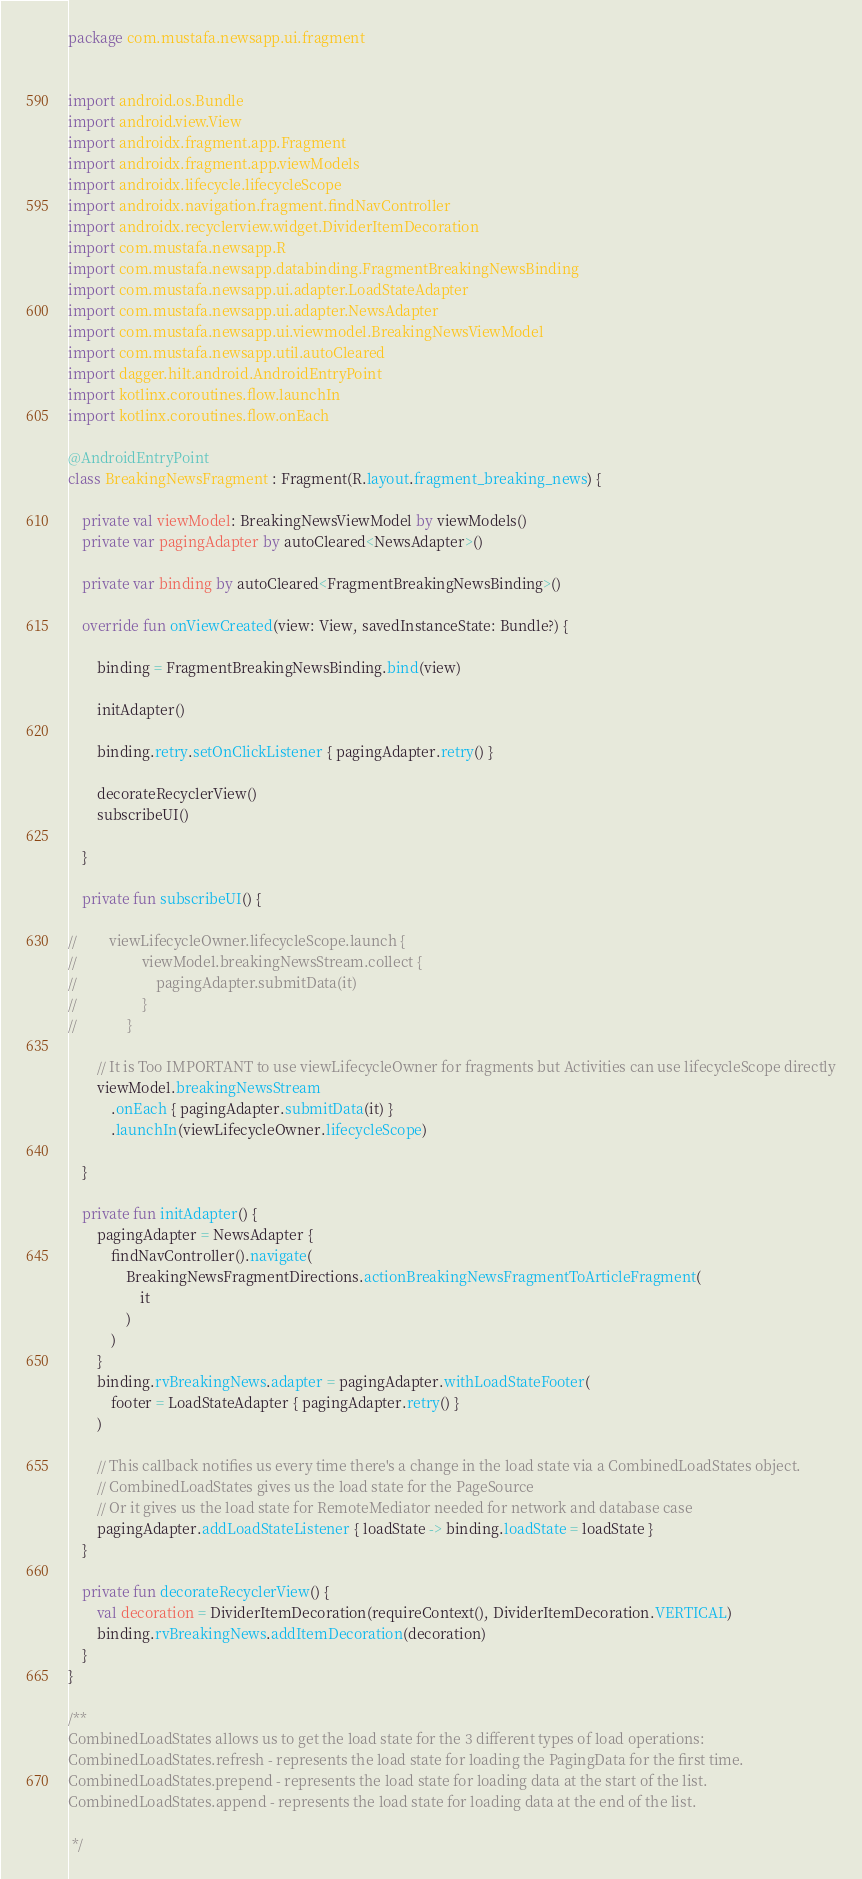Convert code to text. <code><loc_0><loc_0><loc_500><loc_500><_Kotlin_>package com.mustafa.newsapp.ui.fragment


import android.os.Bundle
import android.view.View
import androidx.fragment.app.Fragment
import androidx.fragment.app.viewModels
import androidx.lifecycle.lifecycleScope
import androidx.navigation.fragment.findNavController
import androidx.recyclerview.widget.DividerItemDecoration
import com.mustafa.newsapp.R
import com.mustafa.newsapp.databinding.FragmentBreakingNewsBinding
import com.mustafa.newsapp.ui.adapter.LoadStateAdapter
import com.mustafa.newsapp.ui.adapter.NewsAdapter
import com.mustafa.newsapp.ui.viewmodel.BreakingNewsViewModel
import com.mustafa.newsapp.util.autoCleared
import dagger.hilt.android.AndroidEntryPoint
import kotlinx.coroutines.flow.launchIn
import kotlinx.coroutines.flow.onEach

@AndroidEntryPoint
class BreakingNewsFragment : Fragment(R.layout.fragment_breaking_news) {

    private val viewModel: BreakingNewsViewModel by viewModels()
    private var pagingAdapter by autoCleared<NewsAdapter>()

    private var binding by autoCleared<FragmentBreakingNewsBinding>()

    override fun onViewCreated(view: View, savedInstanceState: Bundle?) {

        binding = FragmentBreakingNewsBinding.bind(view)

        initAdapter()

        binding.retry.setOnClickListener { pagingAdapter.retry() }

        decorateRecyclerView()
        subscribeUI()

    }

    private fun subscribeUI() {

//         viewLifecycleOwner.lifecycleScope.launch {
//                  viewModel.breakingNewsStream.collect {
//                      pagingAdapter.submitData(it)
//                  }
//              }

        // It is Too IMPORTANT to use viewLifecycleOwner for fragments but Activities can use lifecycleScope directly
        viewModel.breakingNewsStream
            .onEach { pagingAdapter.submitData(it) }
            .launchIn(viewLifecycleOwner.lifecycleScope)

    }

    private fun initAdapter() {
        pagingAdapter = NewsAdapter {
            findNavController().navigate(
                BreakingNewsFragmentDirections.actionBreakingNewsFragmentToArticleFragment(
                    it
                )
            )
        }
        binding.rvBreakingNews.adapter = pagingAdapter.withLoadStateFooter(
            footer = LoadStateAdapter { pagingAdapter.retry() }
        )

        // This callback notifies us every time there's a change in the load state via a CombinedLoadStates object.
        // CombinedLoadStates gives us the load state for the PageSource
        // Or it gives us the load state for RemoteMediator needed for network and database case
        pagingAdapter.addLoadStateListener { loadState -> binding.loadState = loadState }
    }

    private fun decorateRecyclerView() {
        val decoration = DividerItemDecoration(requireContext(), DividerItemDecoration.VERTICAL)
        binding.rvBreakingNews.addItemDecoration(decoration)
    }
}

/**
CombinedLoadStates allows us to get the load state for the 3 different types of load operations:
CombinedLoadStates.refresh - represents the load state for loading the PagingData for the first time.
CombinedLoadStates.prepend - represents the load state for loading data at the start of the list.
CombinedLoadStates.append - represents the load state for loading data at the end of the list.

 */</code> 